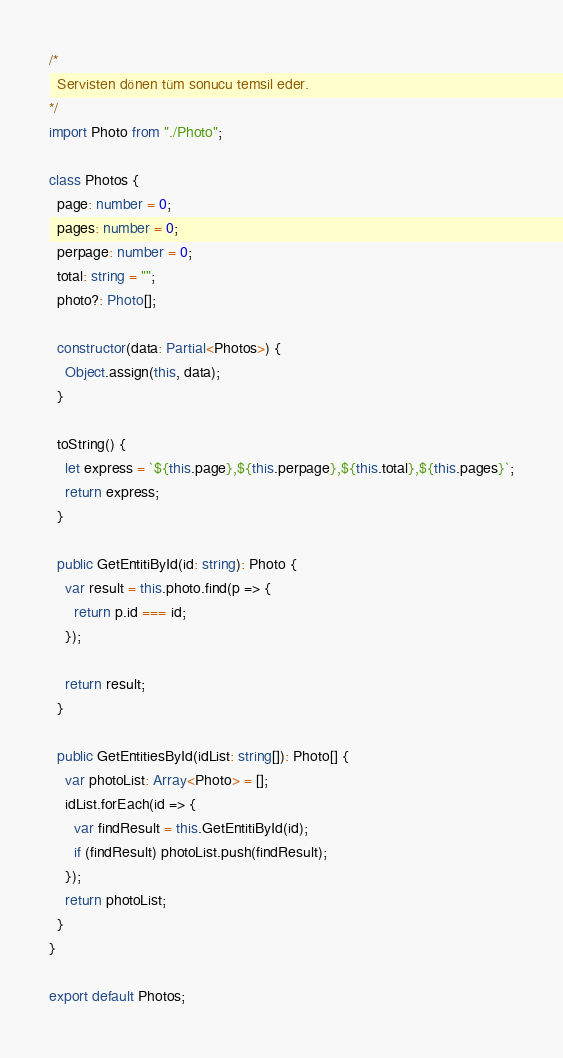<code> <loc_0><loc_0><loc_500><loc_500><_TypeScript_>/*
  Servisten dönen tüm sonucu temsil eder.
*/
import Photo from "./Photo";

class Photos {
  page: number = 0;
  pages: number = 0;
  perpage: number = 0;
  total: string = "";
  photo?: Photo[];

  constructor(data: Partial<Photos>) {
    Object.assign(this, data);
  }

  toString() {
    let express = `${this.page},${this.perpage},${this.total},${this.pages}`;
    return express;
  }

  public GetEntitiById(id: string): Photo {
    var result = this.photo.find(p => {
      return p.id === id;
    });

    return result;
  }

  public GetEntitiesById(idList: string[]): Photo[] {
    var photoList: Array<Photo> = [];
    idList.forEach(id => {
      var findResult = this.GetEntitiById(id);
      if (findResult) photoList.push(findResult);
    });
    return photoList;
  }
}

export default Photos;</code> 